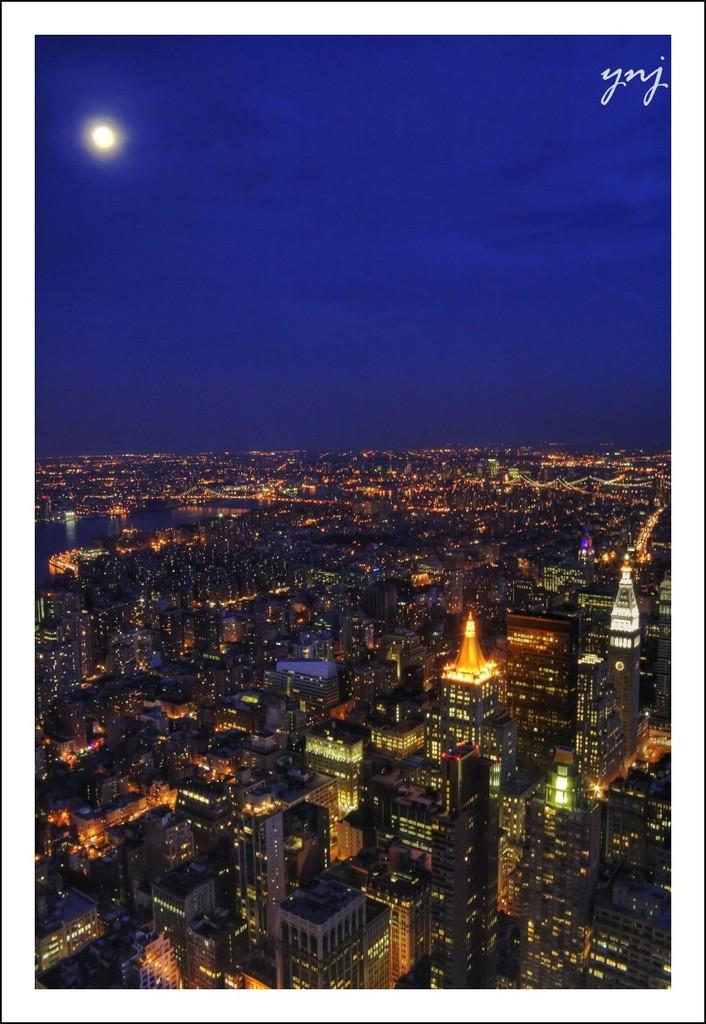What type of view is shown in the image? The image is an aerial view of a city. What structures can be seen in the image? There are buildings visible in the image. What can be seen illuminating the city in the image? Lights are present in the image. What celestial body is visible in the image? The moon is visible in the image. What part of the natural environment is visible in the image? The sky is visible in the image, and clouds are present. What is the tax rate for the city shown in the image? The image does not provide information about the tax rate for the city. What type of border surrounds the city shown in the image? The image does not show any borders surrounding the city. 